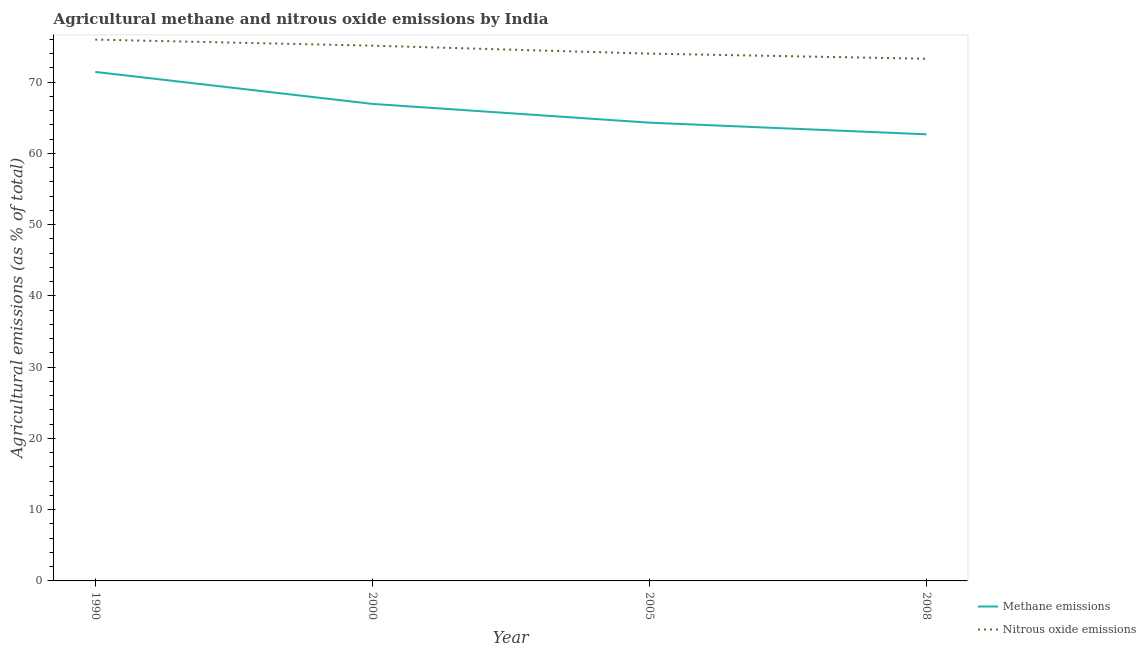How many different coloured lines are there?
Make the answer very short. 2. What is the amount of nitrous oxide emissions in 2000?
Keep it short and to the point. 75.12. Across all years, what is the maximum amount of methane emissions?
Keep it short and to the point. 71.44. Across all years, what is the minimum amount of methane emissions?
Keep it short and to the point. 62.68. In which year was the amount of nitrous oxide emissions minimum?
Make the answer very short. 2008. What is the total amount of methane emissions in the graph?
Your response must be concise. 265.39. What is the difference between the amount of nitrous oxide emissions in 2000 and that in 2005?
Offer a very short reply. 1.12. What is the difference between the amount of methane emissions in 2008 and the amount of nitrous oxide emissions in 2000?
Your answer should be compact. -12.44. What is the average amount of nitrous oxide emissions per year?
Keep it short and to the point. 74.6. In the year 2000, what is the difference between the amount of methane emissions and amount of nitrous oxide emissions?
Your answer should be compact. -8.17. What is the ratio of the amount of nitrous oxide emissions in 1990 to that in 2005?
Provide a succinct answer. 1.03. Is the difference between the amount of methane emissions in 1990 and 2000 greater than the difference between the amount of nitrous oxide emissions in 1990 and 2000?
Your answer should be very brief. Yes. What is the difference between the highest and the second highest amount of nitrous oxide emissions?
Make the answer very short. 0.85. What is the difference between the highest and the lowest amount of nitrous oxide emissions?
Give a very brief answer. 2.69. In how many years, is the amount of nitrous oxide emissions greater than the average amount of nitrous oxide emissions taken over all years?
Your response must be concise. 2. Is the sum of the amount of methane emissions in 1990 and 2008 greater than the maximum amount of nitrous oxide emissions across all years?
Your response must be concise. Yes. Is the amount of methane emissions strictly greater than the amount of nitrous oxide emissions over the years?
Ensure brevity in your answer.  No. How many lines are there?
Keep it short and to the point. 2. Are the values on the major ticks of Y-axis written in scientific E-notation?
Keep it short and to the point. No. Does the graph contain grids?
Offer a very short reply. No. What is the title of the graph?
Provide a short and direct response. Agricultural methane and nitrous oxide emissions by India. What is the label or title of the X-axis?
Provide a succinct answer. Year. What is the label or title of the Y-axis?
Provide a short and direct response. Agricultural emissions (as % of total). What is the Agricultural emissions (as % of total) of Methane emissions in 1990?
Offer a terse response. 71.44. What is the Agricultural emissions (as % of total) of Nitrous oxide emissions in 1990?
Your answer should be very brief. 75.97. What is the Agricultural emissions (as % of total) in Methane emissions in 2000?
Your response must be concise. 66.95. What is the Agricultural emissions (as % of total) in Nitrous oxide emissions in 2000?
Your answer should be very brief. 75.12. What is the Agricultural emissions (as % of total) of Methane emissions in 2005?
Your response must be concise. 64.32. What is the Agricultural emissions (as % of total) in Nitrous oxide emissions in 2005?
Provide a short and direct response. 74.01. What is the Agricultural emissions (as % of total) of Methane emissions in 2008?
Make the answer very short. 62.68. What is the Agricultural emissions (as % of total) of Nitrous oxide emissions in 2008?
Keep it short and to the point. 73.29. Across all years, what is the maximum Agricultural emissions (as % of total) in Methane emissions?
Your answer should be very brief. 71.44. Across all years, what is the maximum Agricultural emissions (as % of total) of Nitrous oxide emissions?
Your response must be concise. 75.97. Across all years, what is the minimum Agricultural emissions (as % of total) of Methane emissions?
Provide a succinct answer. 62.68. Across all years, what is the minimum Agricultural emissions (as % of total) in Nitrous oxide emissions?
Your answer should be very brief. 73.29. What is the total Agricultural emissions (as % of total) of Methane emissions in the graph?
Keep it short and to the point. 265.39. What is the total Agricultural emissions (as % of total) in Nitrous oxide emissions in the graph?
Ensure brevity in your answer.  298.39. What is the difference between the Agricultural emissions (as % of total) of Methane emissions in 1990 and that in 2000?
Keep it short and to the point. 4.49. What is the difference between the Agricultural emissions (as % of total) of Nitrous oxide emissions in 1990 and that in 2000?
Give a very brief answer. 0.85. What is the difference between the Agricultural emissions (as % of total) in Methane emissions in 1990 and that in 2005?
Offer a terse response. 7.12. What is the difference between the Agricultural emissions (as % of total) of Nitrous oxide emissions in 1990 and that in 2005?
Your answer should be very brief. 1.97. What is the difference between the Agricultural emissions (as % of total) of Methane emissions in 1990 and that in 2008?
Keep it short and to the point. 8.76. What is the difference between the Agricultural emissions (as % of total) of Nitrous oxide emissions in 1990 and that in 2008?
Provide a succinct answer. 2.69. What is the difference between the Agricultural emissions (as % of total) of Methane emissions in 2000 and that in 2005?
Your answer should be compact. 2.64. What is the difference between the Agricultural emissions (as % of total) of Nitrous oxide emissions in 2000 and that in 2005?
Your answer should be very brief. 1.12. What is the difference between the Agricultural emissions (as % of total) in Methane emissions in 2000 and that in 2008?
Ensure brevity in your answer.  4.27. What is the difference between the Agricultural emissions (as % of total) in Nitrous oxide emissions in 2000 and that in 2008?
Provide a short and direct response. 1.84. What is the difference between the Agricultural emissions (as % of total) of Methane emissions in 2005 and that in 2008?
Provide a short and direct response. 1.63. What is the difference between the Agricultural emissions (as % of total) of Nitrous oxide emissions in 2005 and that in 2008?
Make the answer very short. 0.72. What is the difference between the Agricultural emissions (as % of total) of Methane emissions in 1990 and the Agricultural emissions (as % of total) of Nitrous oxide emissions in 2000?
Your answer should be compact. -3.68. What is the difference between the Agricultural emissions (as % of total) in Methane emissions in 1990 and the Agricultural emissions (as % of total) in Nitrous oxide emissions in 2005?
Offer a very short reply. -2.57. What is the difference between the Agricultural emissions (as % of total) in Methane emissions in 1990 and the Agricultural emissions (as % of total) in Nitrous oxide emissions in 2008?
Offer a very short reply. -1.85. What is the difference between the Agricultural emissions (as % of total) of Methane emissions in 2000 and the Agricultural emissions (as % of total) of Nitrous oxide emissions in 2005?
Keep it short and to the point. -7.06. What is the difference between the Agricultural emissions (as % of total) in Methane emissions in 2000 and the Agricultural emissions (as % of total) in Nitrous oxide emissions in 2008?
Give a very brief answer. -6.33. What is the difference between the Agricultural emissions (as % of total) in Methane emissions in 2005 and the Agricultural emissions (as % of total) in Nitrous oxide emissions in 2008?
Provide a short and direct response. -8.97. What is the average Agricultural emissions (as % of total) of Methane emissions per year?
Make the answer very short. 66.35. What is the average Agricultural emissions (as % of total) in Nitrous oxide emissions per year?
Keep it short and to the point. 74.6. In the year 1990, what is the difference between the Agricultural emissions (as % of total) of Methane emissions and Agricultural emissions (as % of total) of Nitrous oxide emissions?
Provide a succinct answer. -4.53. In the year 2000, what is the difference between the Agricultural emissions (as % of total) in Methane emissions and Agricultural emissions (as % of total) in Nitrous oxide emissions?
Your answer should be compact. -8.17. In the year 2005, what is the difference between the Agricultural emissions (as % of total) in Methane emissions and Agricultural emissions (as % of total) in Nitrous oxide emissions?
Offer a very short reply. -9.69. In the year 2008, what is the difference between the Agricultural emissions (as % of total) in Methane emissions and Agricultural emissions (as % of total) in Nitrous oxide emissions?
Give a very brief answer. -10.6. What is the ratio of the Agricultural emissions (as % of total) in Methane emissions in 1990 to that in 2000?
Make the answer very short. 1.07. What is the ratio of the Agricultural emissions (as % of total) in Nitrous oxide emissions in 1990 to that in 2000?
Your response must be concise. 1.01. What is the ratio of the Agricultural emissions (as % of total) in Methane emissions in 1990 to that in 2005?
Your answer should be very brief. 1.11. What is the ratio of the Agricultural emissions (as % of total) in Nitrous oxide emissions in 1990 to that in 2005?
Offer a terse response. 1.03. What is the ratio of the Agricultural emissions (as % of total) of Methane emissions in 1990 to that in 2008?
Offer a very short reply. 1.14. What is the ratio of the Agricultural emissions (as % of total) of Nitrous oxide emissions in 1990 to that in 2008?
Your response must be concise. 1.04. What is the ratio of the Agricultural emissions (as % of total) of Methane emissions in 2000 to that in 2005?
Ensure brevity in your answer.  1.04. What is the ratio of the Agricultural emissions (as % of total) in Nitrous oxide emissions in 2000 to that in 2005?
Make the answer very short. 1.02. What is the ratio of the Agricultural emissions (as % of total) in Methane emissions in 2000 to that in 2008?
Your answer should be very brief. 1.07. What is the ratio of the Agricultural emissions (as % of total) in Nitrous oxide emissions in 2000 to that in 2008?
Ensure brevity in your answer.  1.03. What is the ratio of the Agricultural emissions (as % of total) in Methane emissions in 2005 to that in 2008?
Ensure brevity in your answer.  1.03. What is the ratio of the Agricultural emissions (as % of total) of Nitrous oxide emissions in 2005 to that in 2008?
Make the answer very short. 1.01. What is the difference between the highest and the second highest Agricultural emissions (as % of total) of Methane emissions?
Give a very brief answer. 4.49. What is the difference between the highest and the second highest Agricultural emissions (as % of total) of Nitrous oxide emissions?
Offer a very short reply. 0.85. What is the difference between the highest and the lowest Agricultural emissions (as % of total) of Methane emissions?
Your answer should be very brief. 8.76. What is the difference between the highest and the lowest Agricultural emissions (as % of total) in Nitrous oxide emissions?
Your answer should be compact. 2.69. 